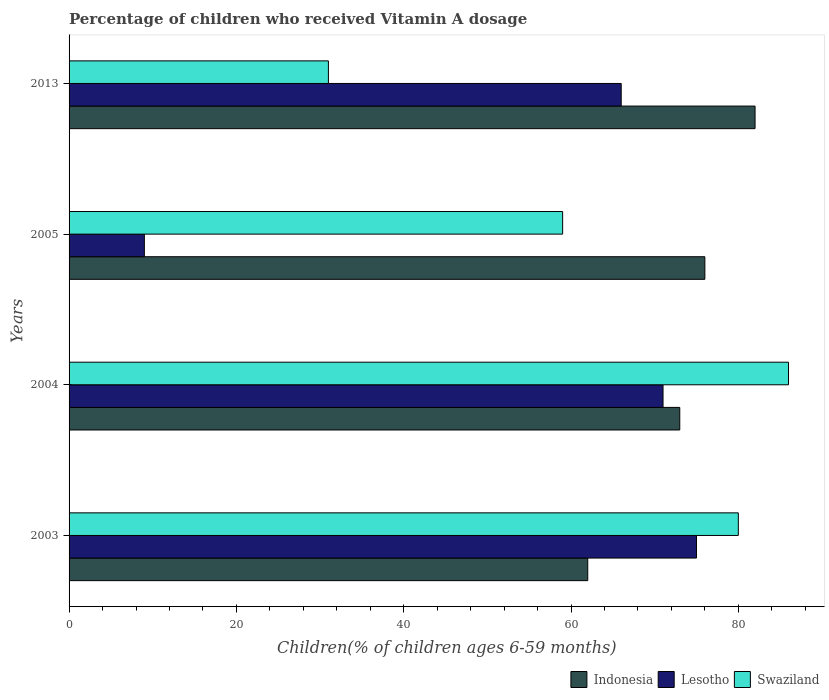Are the number of bars on each tick of the Y-axis equal?
Offer a very short reply. Yes. How many bars are there on the 1st tick from the top?
Provide a short and direct response. 3. How many bars are there on the 3rd tick from the bottom?
Keep it short and to the point. 3. What is the label of the 2nd group of bars from the top?
Your response must be concise. 2005. What is the percentage of children who received Vitamin A dosage in Lesotho in 2003?
Give a very brief answer. 75. Across all years, what is the maximum percentage of children who received Vitamin A dosage in Lesotho?
Offer a terse response. 75. In which year was the percentage of children who received Vitamin A dosage in Swaziland maximum?
Offer a terse response. 2004. In which year was the percentage of children who received Vitamin A dosage in Lesotho minimum?
Provide a succinct answer. 2005. What is the total percentage of children who received Vitamin A dosage in Indonesia in the graph?
Offer a very short reply. 293. What is the difference between the percentage of children who received Vitamin A dosage in Lesotho in 2004 and the percentage of children who received Vitamin A dosage in Swaziland in 2003?
Offer a very short reply. -9. What is the average percentage of children who received Vitamin A dosage in Swaziland per year?
Provide a short and direct response. 64. In how many years, is the percentage of children who received Vitamin A dosage in Swaziland greater than 72 %?
Your answer should be very brief. 2. What is the ratio of the percentage of children who received Vitamin A dosage in Lesotho in 2003 to that in 2004?
Offer a terse response. 1.06. In how many years, is the percentage of children who received Vitamin A dosage in Indonesia greater than the average percentage of children who received Vitamin A dosage in Indonesia taken over all years?
Offer a terse response. 2. Is the sum of the percentage of children who received Vitamin A dosage in Indonesia in 2003 and 2005 greater than the maximum percentage of children who received Vitamin A dosage in Lesotho across all years?
Provide a succinct answer. Yes. What does the 3rd bar from the top in 2003 represents?
Make the answer very short. Indonesia. What does the 2nd bar from the bottom in 2003 represents?
Offer a terse response. Lesotho. Is it the case that in every year, the sum of the percentage of children who received Vitamin A dosage in Indonesia and percentage of children who received Vitamin A dosage in Lesotho is greater than the percentage of children who received Vitamin A dosage in Swaziland?
Give a very brief answer. Yes. How many bars are there?
Provide a short and direct response. 12. How many years are there in the graph?
Provide a short and direct response. 4. What is the difference between two consecutive major ticks on the X-axis?
Offer a very short reply. 20. Where does the legend appear in the graph?
Offer a very short reply. Bottom right. How are the legend labels stacked?
Make the answer very short. Horizontal. What is the title of the graph?
Offer a terse response. Percentage of children who received Vitamin A dosage. What is the label or title of the X-axis?
Keep it short and to the point. Children(% of children ages 6-59 months). What is the label or title of the Y-axis?
Ensure brevity in your answer.  Years. What is the Children(% of children ages 6-59 months) of Lesotho in 2003?
Make the answer very short. 75. What is the Children(% of children ages 6-59 months) in Swaziland in 2003?
Ensure brevity in your answer.  80. What is the Children(% of children ages 6-59 months) of Lesotho in 2004?
Make the answer very short. 71. What is the Children(% of children ages 6-59 months) in Swaziland in 2013?
Offer a terse response. 31. Across all years, what is the maximum Children(% of children ages 6-59 months) in Indonesia?
Ensure brevity in your answer.  82. Across all years, what is the maximum Children(% of children ages 6-59 months) in Swaziland?
Provide a short and direct response. 86. Across all years, what is the minimum Children(% of children ages 6-59 months) in Lesotho?
Your answer should be compact. 9. Across all years, what is the minimum Children(% of children ages 6-59 months) of Swaziland?
Your response must be concise. 31. What is the total Children(% of children ages 6-59 months) of Indonesia in the graph?
Your answer should be very brief. 293. What is the total Children(% of children ages 6-59 months) of Lesotho in the graph?
Your response must be concise. 221. What is the total Children(% of children ages 6-59 months) of Swaziland in the graph?
Provide a short and direct response. 256. What is the difference between the Children(% of children ages 6-59 months) of Lesotho in 2003 and that in 2005?
Offer a very short reply. 66. What is the difference between the Children(% of children ages 6-59 months) of Swaziland in 2003 and that in 2005?
Offer a terse response. 21. What is the difference between the Children(% of children ages 6-59 months) in Indonesia in 2003 and that in 2013?
Give a very brief answer. -20. What is the difference between the Children(% of children ages 6-59 months) in Lesotho in 2003 and that in 2013?
Provide a succinct answer. 9. What is the difference between the Children(% of children ages 6-59 months) of Swaziland in 2003 and that in 2013?
Provide a succinct answer. 49. What is the difference between the Children(% of children ages 6-59 months) of Swaziland in 2004 and that in 2005?
Make the answer very short. 27. What is the difference between the Children(% of children ages 6-59 months) of Indonesia in 2004 and that in 2013?
Ensure brevity in your answer.  -9. What is the difference between the Children(% of children ages 6-59 months) of Lesotho in 2004 and that in 2013?
Your response must be concise. 5. What is the difference between the Children(% of children ages 6-59 months) of Swaziland in 2004 and that in 2013?
Ensure brevity in your answer.  55. What is the difference between the Children(% of children ages 6-59 months) in Lesotho in 2005 and that in 2013?
Give a very brief answer. -57. What is the difference between the Children(% of children ages 6-59 months) of Swaziland in 2005 and that in 2013?
Provide a succinct answer. 28. What is the difference between the Children(% of children ages 6-59 months) in Indonesia in 2003 and the Children(% of children ages 6-59 months) in Lesotho in 2004?
Your answer should be compact. -9. What is the difference between the Children(% of children ages 6-59 months) in Indonesia in 2003 and the Children(% of children ages 6-59 months) in Swaziland in 2004?
Offer a terse response. -24. What is the difference between the Children(% of children ages 6-59 months) in Indonesia in 2003 and the Children(% of children ages 6-59 months) in Lesotho in 2005?
Provide a short and direct response. 53. What is the difference between the Children(% of children ages 6-59 months) of Indonesia in 2004 and the Children(% of children ages 6-59 months) of Lesotho in 2005?
Provide a succinct answer. 64. What is the difference between the Children(% of children ages 6-59 months) in Indonesia in 2004 and the Children(% of children ages 6-59 months) in Swaziland in 2005?
Provide a short and direct response. 14. What is the difference between the Children(% of children ages 6-59 months) in Indonesia in 2004 and the Children(% of children ages 6-59 months) in Lesotho in 2013?
Give a very brief answer. 7. What is the difference between the Children(% of children ages 6-59 months) of Lesotho in 2004 and the Children(% of children ages 6-59 months) of Swaziland in 2013?
Your answer should be compact. 40. What is the difference between the Children(% of children ages 6-59 months) of Indonesia in 2005 and the Children(% of children ages 6-59 months) of Lesotho in 2013?
Keep it short and to the point. 10. What is the difference between the Children(% of children ages 6-59 months) in Lesotho in 2005 and the Children(% of children ages 6-59 months) in Swaziland in 2013?
Give a very brief answer. -22. What is the average Children(% of children ages 6-59 months) in Indonesia per year?
Your answer should be compact. 73.25. What is the average Children(% of children ages 6-59 months) in Lesotho per year?
Your answer should be compact. 55.25. What is the average Children(% of children ages 6-59 months) of Swaziland per year?
Give a very brief answer. 64. In the year 2003, what is the difference between the Children(% of children ages 6-59 months) in Indonesia and Children(% of children ages 6-59 months) in Swaziland?
Your answer should be very brief. -18. In the year 2003, what is the difference between the Children(% of children ages 6-59 months) in Lesotho and Children(% of children ages 6-59 months) in Swaziland?
Your response must be concise. -5. In the year 2004, what is the difference between the Children(% of children ages 6-59 months) of Indonesia and Children(% of children ages 6-59 months) of Swaziland?
Provide a short and direct response. -13. In the year 2005, what is the difference between the Children(% of children ages 6-59 months) of Indonesia and Children(% of children ages 6-59 months) of Lesotho?
Make the answer very short. 67. In the year 2013, what is the difference between the Children(% of children ages 6-59 months) of Indonesia and Children(% of children ages 6-59 months) of Lesotho?
Make the answer very short. 16. In the year 2013, what is the difference between the Children(% of children ages 6-59 months) of Indonesia and Children(% of children ages 6-59 months) of Swaziland?
Offer a very short reply. 51. What is the ratio of the Children(% of children ages 6-59 months) in Indonesia in 2003 to that in 2004?
Provide a succinct answer. 0.85. What is the ratio of the Children(% of children ages 6-59 months) of Lesotho in 2003 to that in 2004?
Keep it short and to the point. 1.06. What is the ratio of the Children(% of children ages 6-59 months) of Swaziland in 2003 to that in 2004?
Ensure brevity in your answer.  0.93. What is the ratio of the Children(% of children ages 6-59 months) in Indonesia in 2003 to that in 2005?
Your answer should be compact. 0.82. What is the ratio of the Children(% of children ages 6-59 months) in Lesotho in 2003 to that in 2005?
Keep it short and to the point. 8.33. What is the ratio of the Children(% of children ages 6-59 months) in Swaziland in 2003 to that in 2005?
Provide a short and direct response. 1.36. What is the ratio of the Children(% of children ages 6-59 months) in Indonesia in 2003 to that in 2013?
Your answer should be very brief. 0.76. What is the ratio of the Children(% of children ages 6-59 months) of Lesotho in 2003 to that in 2013?
Your answer should be very brief. 1.14. What is the ratio of the Children(% of children ages 6-59 months) in Swaziland in 2003 to that in 2013?
Keep it short and to the point. 2.58. What is the ratio of the Children(% of children ages 6-59 months) in Indonesia in 2004 to that in 2005?
Provide a short and direct response. 0.96. What is the ratio of the Children(% of children ages 6-59 months) in Lesotho in 2004 to that in 2005?
Provide a short and direct response. 7.89. What is the ratio of the Children(% of children ages 6-59 months) in Swaziland in 2004 to that in 2005?
Your answer should be very brief. 1.46. What is the ratio of the Children(% of children ages 6-59 months) in Indonesia in 2004 to that in 2013?
Ensure brevity in your answer.  0.89. What is the ratio of the Children(% of children ages 6-59 months) of Lesotho in 2004 to that in 2013?
Provide a succinct answer. 1.08. What is the ratio of the Children(% of children ages 6-59 months) in Swaziland in 2004 to that in 2013?
Offer a terse response. 2.77. What is the ratio of the Children(% of children ages 6-59 months) of Indonesia in 2005 to that in 2013?
Keep it short and to the point. 0.93. What is the ratio of the Children(% of children ages 6-59 months) of Lesotho in 2005 to that in 2013?
Your answer should be very brief. 0.14. What is the ratio of the Children(% of children ages 6-59 months) in Swaziland in 2005 to that in 2013?
Provide a succinct answer. 1.9. What is the difference between the highest and the lowest Children(% of children ages 6-59 months) of Lesotho?
Provide a short and direct response. 66. What is the difference between the highest and the lowest Children(% of children ages 6-59 months) in Swaziland?
Provide a succinct answer. 55. 